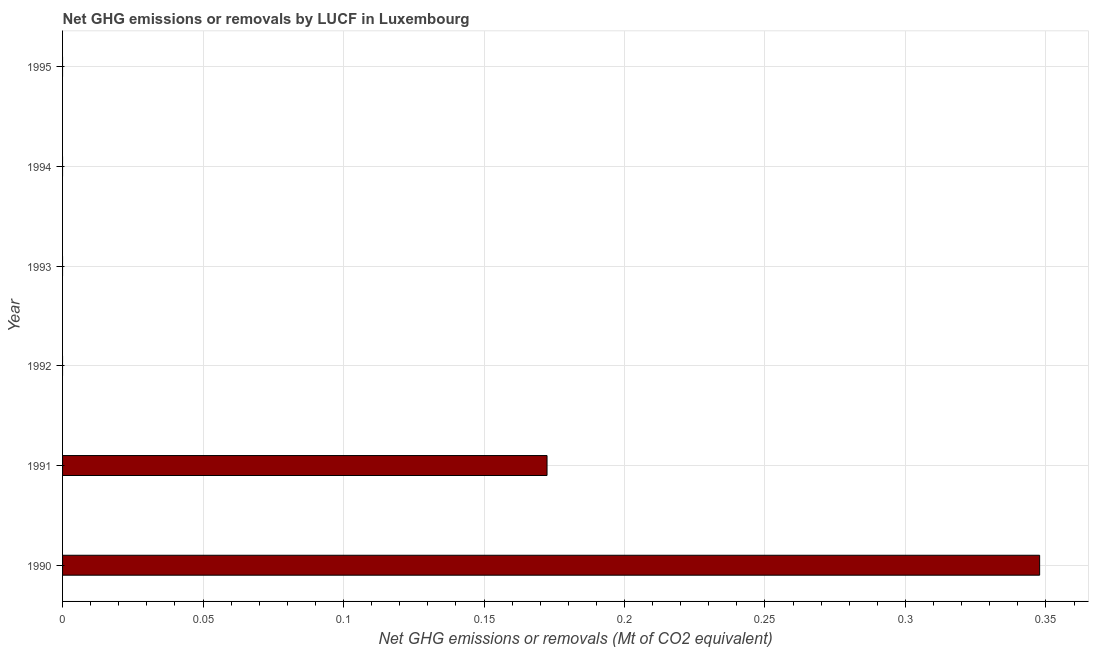Does the graph contain any zero values?
Provide a short and direct response. Yes. Does the graph contain grids?
Your response must be concise. Yes. What is the title of the graph?
Provide a succinct answer. Net GHG emissions or removals by LUCF in Luxembourg. What is the label or title of the X-axis?
Offer a very short reply. Net GHG emissions or removals (Mt of CO2 equivalent). What is the label or title of the Y-axis?
Provide a succinct answer. Year. Across all years, what is the maximum ghg net emissions or removals?
Offer a terse response. 0.35. What is the sum of the ghg net emissions or removals?
Offer a very short reply. 0.52. What is the difference between the ghg net emissions or removals in 1990 and 1991?
Offer a very short reply. 0.17. What is the average ghg net emissions or removals per year?
Offer a terse response. 0.09. What is the median ghg net emissions or removals?
Offer a very short reply. 0. In how many years, is the ghg net emissions or removals greater than 0.07 Mt?
Offer a terse response. 2. What is the ratio of the ghg net emissions or removals in 1990 to that in 1991?
Your answer should be very brief. 2.02. Is the difference between the ghg net emissions or removals in 1990 and 1991 greater than the difference between any two years?
Ensure brevity in your answer.  No. What is the difference between the highest and the lowest ghg net emissions or removals?
Make the answer very short. 0.35. Are all the bars in the graph horizontal?
Give a very brief answer. Yes. How many years are there in the graph?
Provide a succinct answer. 6. What is the difference between two consecutive major ticks on the X-axis?
Your answer should be very brief. 0.05. Are the values on the major ticks of X-axis written in scientific E-notation?
Keep it short and to the point. No. What is the Net GHG emissions or removals (Mt of CO2 equivalent) of 1990?
Provide a short and direct response. 0.35. What is the Net GHG emissions or removals (Mt of CO2 equivalent) of 1991?
Ensure brevity in your answer.  0.17. What is the Net GHG emissions or removals (Mt of CO2 equivalent) in 1993?
Provide a succinct answer. 0. What is the Net GHG emissions or removals (Mt of CO2 equivalent) of 1994?
Offer a terse response. 0. What is the difference between the Net GHG emissions or removals (Mt of CO2 equivalent) in 1990 and 1991?
Your answer should be compact. 0.18. What is the ratio of the Net GHG emissions or removals (Mt of CO2 equivalent) in 1990 to that in 1991?
Ensure brevity in your answer.  2.02. 